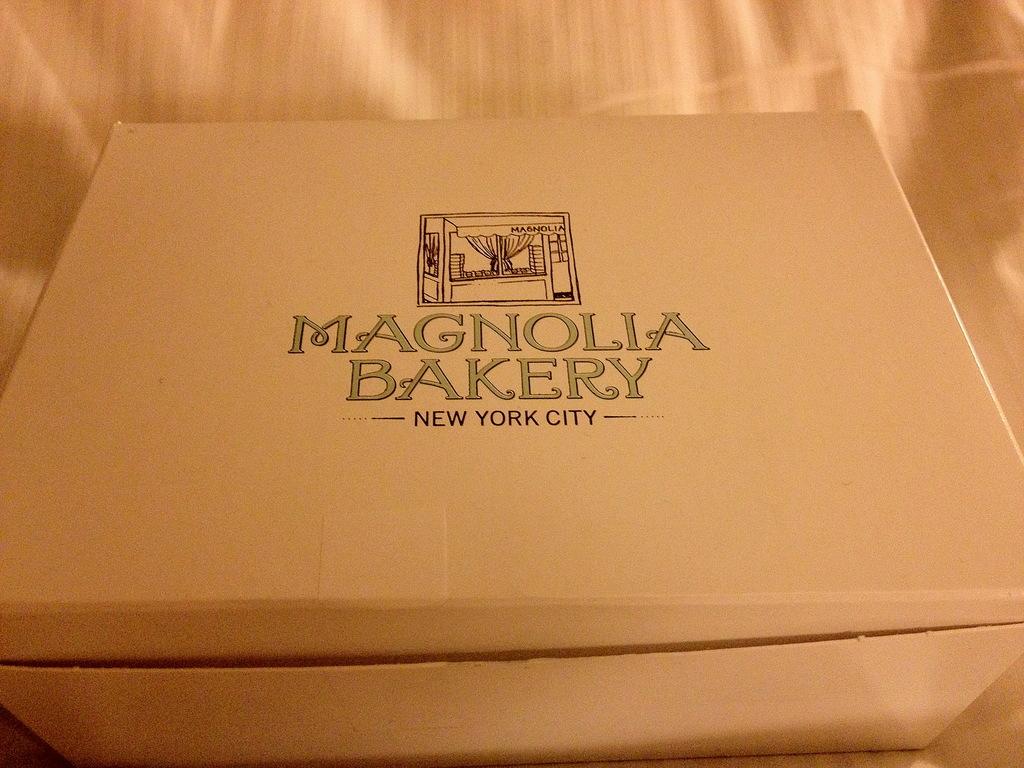What's the name of this bakery?
Keep it short and to the point. Magnolia bakery. Where is this bakery located?
Ensure brevity in your answer.  New york city. 